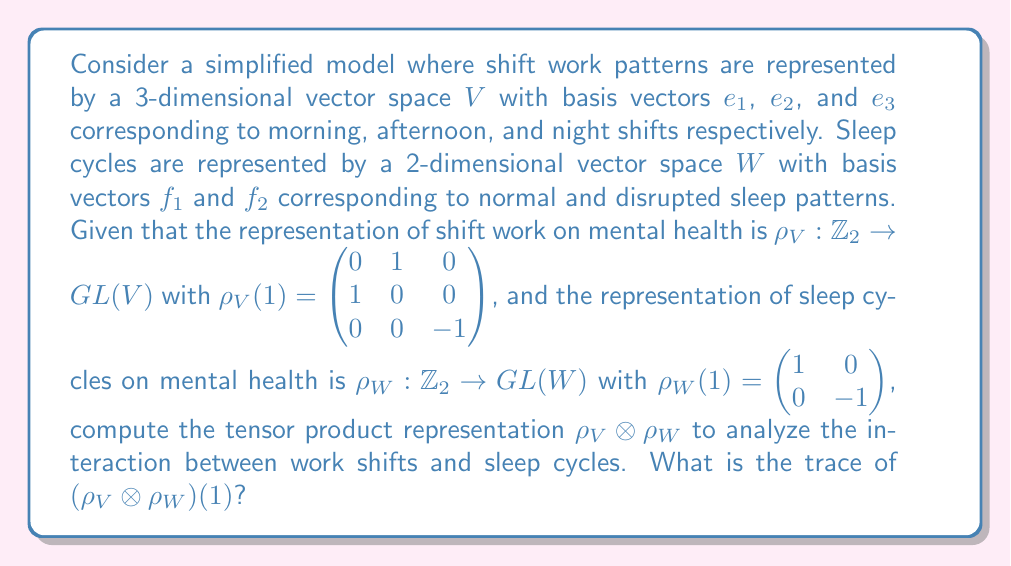Give your solution to this math problem. To analyze the interaction between work shifts and sleep cycles using representation theory, we need to compute the tensor product of the given representations. Let's proceed step-by-step:

1) The tensor product representation $\rho_V \otimes \rho_W$ acts on the space $V \otimes W$, which has dimension $3 \times 2 = 6$.

2) To compute $(\rho_V \otimes \rho_W)(1)$, we use the property that $(A \otimes B)(v \otimes w) = (Av) \otimes (Bw)$. This means we need to compute the Kronecker product of the matrices $\rho_V(1)$ and $\rho_W(1)$.

3) The Kronecker product is computed as follows:

   $$(\rho_V \otimes \rho_W)(1) = \rho_V(1) \otimes \rho_W(1) = 
   \begin{pmatrix} 
   0 & 1 & 0 \\ 
   1 & 0 & 0 \\ 
   0 & 0 & -1
   \end{pmatrix} \otimes 
   \begin{pmatrix} 
   1 & 0 \\ 
   0 & -1
   \end{pmatrix}$$

4) Computing this Kronecker product:

   $$(\rho_V \otimes \rho_W)(1) = 
   \begin{pmatrix} 
   0 & 0 & 1 & 0 & 0 & 0 \\
   0 & 0 & 0 & -1 & 0 & 0 \\
   1 & 0 & 0 & 0 & 0 & 0 \\
   0 & -1 & 0 & 0 & 0 & 0 \\
   0 & 0 & 0 & 0 & -1 & 0 \\
   0 & 0 & 0 & 0 & 0 & 1
   \end{pmatrix}$$

5) The trace of a matrix is the sum of its diagonal elements. In this case:

   $Tr((\rho_V \otimes \rho_W)(1)) = 0 + 0 + 0 + 0 + (-1) + 1 = 0$

This result indicates that the combined effect of shift work and sleep cycles on mental health, as modeled by this representation, has a net zero trace. In representation theory, the trace of a group element's action is related to the character of the representation, which can provide insights into the structure of the representation and its decomposition into irreducible components.
Answer: $0$ 